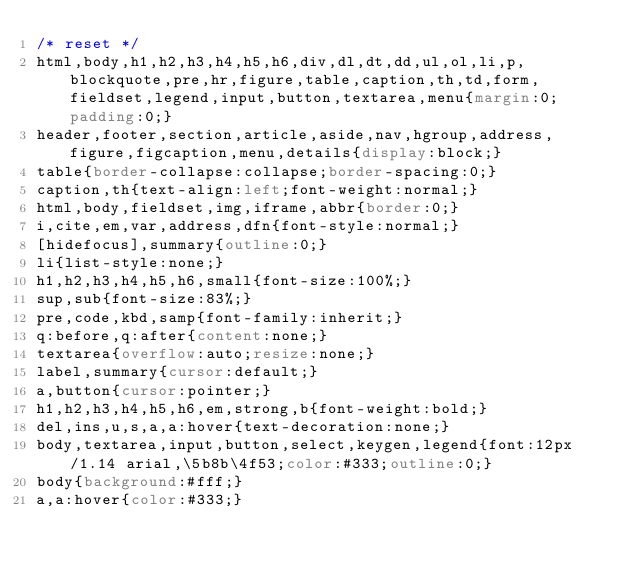<code> <loc_0><loc_0><loc_500><loc_500><_CSS_>/* reset */
html,body,h1,h2,h3,h4,h5,h6,div,dl,dt,dd,ul,ol,li,p,blockquote,pre,hr,figure,table,caption,th,td,form,fieldset,legend,input,button,textarea,menu{margin:0;padding:0;}
header,footer,section,article,aside,nav,hgroup,address,figure,figcaption,menu,details{display:block;}
table{border-collapse:collapse;border-spacing:0;}
caption,th{text-align:left;font-weight:normal;}
html,body,fieldset,img,iframe,abbr{border:0;}
i,cite,em,var,address,dfn{font-style:normal;}
[hidefocus],summary{outline:0;}
li{list-style:none;}
h1,h2,h3,h4,h5,h6,small{font-size:100%;}
sup,sub{font-size:83%;}
pre,code,kbd,samp{font-family:inherit;}
q:before,q:after{content:none;}
textarea{overflow:auto;resize:none;}
label,summary{cursor:default;}
a,button{cursor:pointer;}
h1,h2,h3,h4,h5,h6,em,strong,b{font-weight:bold;}
del,ins,u,s,a,a:hover{text-decoration:none;}
body,textarea,input,button,select,keygen,legend{font:12px/1.14 arial,\5b8b\4f53;color:#333;outline:0;}
body{background:#fff;}
a,a:hover{color:#333;}
</code> 